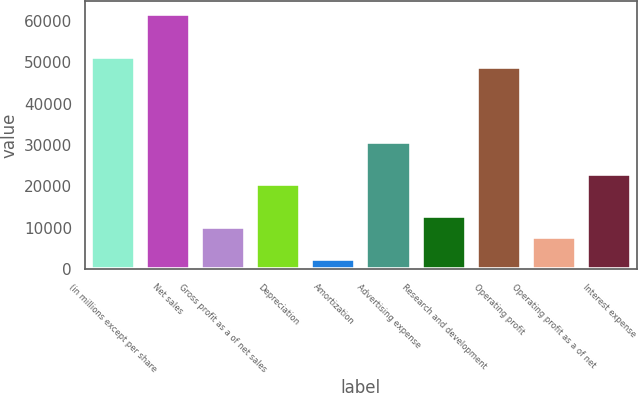Convert chart. <chart><loc_0><loc_0><loc_500><loc_500><bar_chart><fcel>(in millions except per share<fcel>Net sales<fcel>Gross profit as a of net sales<fcel>Depreciation<fcel>Amortization<fcel>Advertising expense<fcel>Research and development<fcel>Operating profit<fcel>Operating profit as a of net<fcel>Interest expense<nl><fcel>51351<fcel>61621<fcel>10271<fcel>20541<fcel>2568.51<fcel>30811<fcel>12838.5<fcel>48783.5<fcel>7703.51<fcel>23108.5<nl></chart> 